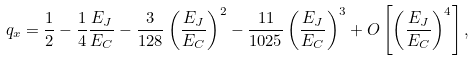Convert formula to latex. <formula><loc_0><loc_0><loc_500><loc_500>q _ { x } = \frac { 1 } { 2 } - \frac { 1 } { 4 } \frac { E _ { J } } { E _ { C } } - \frac { 3 } { 1 2 8 } \left ( \frac { E _ { J } } { E _ { C } } \right ) ^ { 2 } - \frac { 1 1 } { 1 0 2 5 } \left ( \frac { E _ { J } } { E _ { C } } \right ) ^ { 3 } + O \left [ \left ( \frac { E _ { J } } { E _ { C } } \right ) ^ { 4 } \right ] ,</formula> 